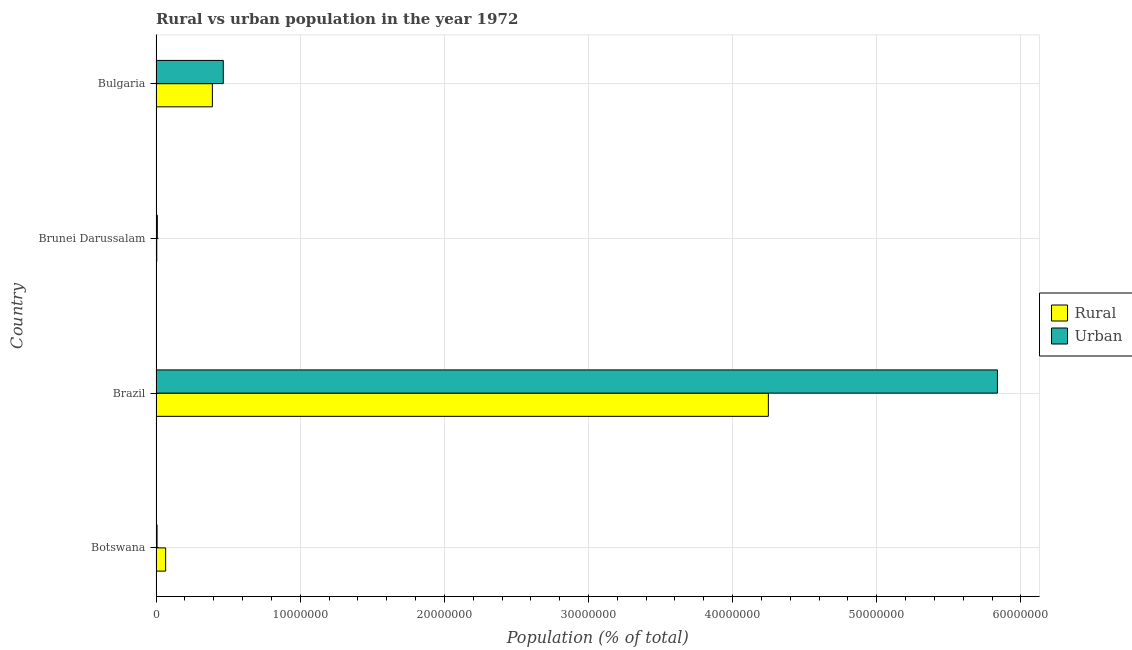Are the number of bars per tick equal to the number of legend labels?
Your response must be concise. Yes. Are the number of bars on each tick of the Y-axis equal?
Provide a succinct answer. Yes. How many bars are there on the 4th tick from the top?
Make the answer very short. 2. What is the label of the 2nd group of bars from the top?
Offer a terse response. Brunei Darussalam. In how many cases, is the number of bars for a given country not equal to the number of legend labels?
Provide a succinct answer. 0. What is the rural population density in Brazil?
Offer a very short reply. 4.25e+07. Across all countries, what is the maximum urban population density?
Your answer should be compact. 5.84e+07. Across all countries, what is the minimum rural population density?
Ensure brevity in your answer.  5.21e+04. In which country was the rural population density minimum?
Give a very brief answer. Brunei Darussalam. What is the total urban population density in the graph?
Offer a very short reply. 6.32e+07. What is the difference between the rural population density in Botswana and that in Bulgaria?
Your answer should be compact. -3.24e+06. What is the difference between the urban population density in Bulgaria and the rural population density in Brunei Darussalam?
Keep it short and to the point. 4.61e+06. What is the average urban population density per country?
Offer a very short reply. 1.58e+07. What is the difference between the rural population density and urban population density in Botswana?
Provide a short and direct response. 5.96e+05. What is the ratio of the rural population density in Brunei Darussalam to that in Bulgaria?
Ensure brevity in your answer.  0.01. What is the difference between the highest and the second highest rural population density?
Offer a very short reply. 3.86e+07. What is the difference between the highest and the lowest rural population density?
Your answer should be compact. 4.24e+07. What does the 1st bar from the top in Bulgaria represents?
Provide a short and direct response. Urban. What does the 2nd bar from the bottom in Botswana represents?
Make the answer very short. Urban. How many countries are there in the graph?
Offer a very short reply. 4. What is the difference between two consecutive major ticks on the X-axis?
Make the answer very short. 1.00e+07. Does the graph contain any zero values?
Your answer should be compact. No. Does the graph contain grids?
Keep it short and to the point. Yes. How many legend labels are there?
Provide a succinct answer. 2. How are the legend labels stacked?
Provide a succinct answer. Vertical. What is the title of the graph?
Your response must be concise. Rural vs urban population in the year 1972. What is the label or title of the X-axis?
Your response must be concise. Population (% of total). What is the Population (% of total) in Rural in Botswana?
Offer a terse response. 6.68e+05. What is the Population (% of total) in Urban in Botswana?
Offer a terse response. 7.17e+04. What is the Population (% of total) of Rural in Brazil?
Provide a short and direct response. 4.25e+07. What is the Population (% of total) in Urban in Brazil?
Your response must be concise. 5.84e+07. What is the Population (% of total) of Rural in Brunei Darussalam?
Your answer should be compact. 5.21e+04. What is the Population (% of total) of Urban in Brunei Darussalam?
Keep it short and to the point. 8.97e+04. What is the Population (% of total) of Rural in Bulgaria?
Your response must be concise. 3.91e+06. What is the Population (% of total) of Urban in Bulgaria?
Provide a short and direct response. 4.67e+06. Across all countries, what is the maximum Population (% of total) of Rural?
Offer a very short reply. 4.25e+07. Across all countries, what is the maximum Population (% of total) of Urban?
Provide a succinct answer. 5.84e+07. Across all countries, what is the minimum Population (% of total) of Rural?
Keep it short and to the point. 5.21e+04. Across all countries, what is the minimum Population (% of total) in Urban?
Offer a very short reply. 7.17e+04. What is the total Population (% of total) of Rural in the graph?
Offer a terse response. 4.71e+07. What is the total Population (% of total) of Urban in the graph?
Your response must be concise. 6.32e+07. What is the difference between the Population (% of total) in Rural in Botswana and that in Brazil?
Your answer should be compact. -4.18e+07. What is the difference between the Population (% of total) of Urban in Botswana and that in Brazil?
Provide a succinct answer. -5.83e+07. What is the difference between the Population (% of total) in Rural in Botswana and that in Brunei Darussalam?
Offer a very short reply. 6.16e+05. What is the difference between the Population (% of total) in Urban in Botswana and that in Brunei Darussalam?
Provide a succinct answer. -1.80e+04. What is the difference between the Population (% of total) in Rural in Botswana and that in Bulgaria?
Your answer should be compact. -3.24e+06. What is the difference between the Population (% of total) in Urban in Botswana and that in Bulgaria?
Give a very brief answer. -4.60e+06. What is the difference between the Population (% of total) of Rural in Brazil and that in Brunei Darussalam?
Provide a succinct answer. 4.24e+07. What is the difference between the Population (% of total) of Urban in Brazil and that in Brunei Darussalam?
Keep it short and to the point. 5.83e+07. What is the difference between the Population (% of total) of Rural in Brazil and that in Bulgaria?
Offer a terse response. 3.86e+07. What is the difference between the Population (% of total) of Urban in Brazil and that in Bulgaria?
Offer a terse response. 5.37e+07. What is the difference between the Population (% of total) of Rural in Brunei Darussalam and that in Bulgaria?
Keep it short and to the point. -3.86e+06. What is the difference between the Population (% of total) in Urban in Brunei Darussalam and that in Bulgaria?
Offer a terse response. -4.58e+06. What is the difference between the Population (% of total) in Rural in Botswana and the Population (% of total) in Urban in Brazil?
Your response must be concise. -5.77e+07. What is the difference between the Population (% of total) in Rural in Botswana and the Population (% of total) in Urban in Brunei Darussalam?
Give a very brief answer. 5.78e+05. What is the difference between the Population (% of total) of Rural in Botswana and the Population (% of total) of Urban in Bulgaria?
Your answer should be compact. -4.00e+06. What is the difference between the Population (% of total) in Rural in Brazil and the Population (% of total) in Urban in Brunei Darussalam?
Ensure brevity in your answer.  4.24e+07. What is the difference between the Population (% of total) in Rural in Brazil and the Population (% of total) in Urban in Bulgaria?
Offer a terse response. 3.78e+07. What is the difference between the Population (% of total) of Rural in Brunei Darussalam and the Population (% of total) of Urban in Bulgaria?
Ensure brevity in your answer.  -4.61e+06. What is the average Population (% of total) in Rural per country?
Ensure brevity in your answer.  1.18e+07. What is the average Population (% of total) of Urban per country?
Keep it short and to the point. 1.58e+07. What is the difference between the Population (% of total) of Rural and Population (% of total) of Urban in Botswana?
Give a very brief answer. 5.96e+05. What is the difference between the Population (% of total) in Rural and Population (% of total) in Urban in Brazil?
Make the answer very short. -1.59e+07. What is the difference between the Population (% of total) in Rural and Population (% of total) in Urban in Brunei Darussalam?
Ensure brevity in your answer.  -3.75e+04. What is the difference between the Population (% of total) in Rural and Population (% of total) in Urban in Bulgaria?
Make the answer very short. -7.58e+05. What is the ratio of the Population (% of total) of Rural in Botswana to that in Brazil?
Provide a short and direct response. 0.02. What is the ratio of the Population (% of total) in Urban in Botswana to that in Brazil?
Offer a very short reply. 0. What is the ratio of the Population (% of total) of Rural in Botswana to that in Brunei Darussalam?
Offer a very short reply. 12.81. What is the ratio of the Population (% of total) of Urban in Botswana to that in Brunei Darussalam?
Offer a very short reply. 0.8. What is the ratio of the Population (% of total) in Rural in Botswana to that in Bulgaria?
Ensure brevity in your answer.  0.17. What is the ratio of the Population (% of total) in Urban in Botswana to that in Bulgaria?
Offer a terse response. 0.02. What is the ratio of the Population (% of total) in Rural in Brazil to that in Brunei Darussalam?
Your answer should be very brief. 814.56. What is the ratio of the Population (% of total) of Urban in Brazil to that in Brunei Darussalam?
Offer a terse response. 650.78. What is the ratio of the Population (% of total) in Rural in Brazil to that in Bulgaria?
Keep it short and to the point. 10.87. What is the ratio of the Population (% of total) of Urban in Brazil to that in Bulgaria?
Offer a terse response. 12.51. What is the ratio of the Population (% of total) of Rural in Brunei Darussalam to that in Bulgaria?
Ensure brevity in your answer.  0.01. What is the ratio of the Population (% of total) in Urban in Brunei Darussalam to that in Bulgaria?
Ensure brevity in your answer.  0.02. What is the difference between the highest and the second highest Population (% of total) of Rural?
Your answer should be very brief. 3.86e+07. What is the difference between the highest and the second highest Population (% of total) of Urban?
Make the answer very short. 5.37e+07. What is the difference between the highest and the lowest Population (% of total) of Rural?
Your response must be concise. 4.24e+07. What is the difference between the highest and the lowest Population (% of total) in Urban?
Your answer should be compact. 5.83e+07. 